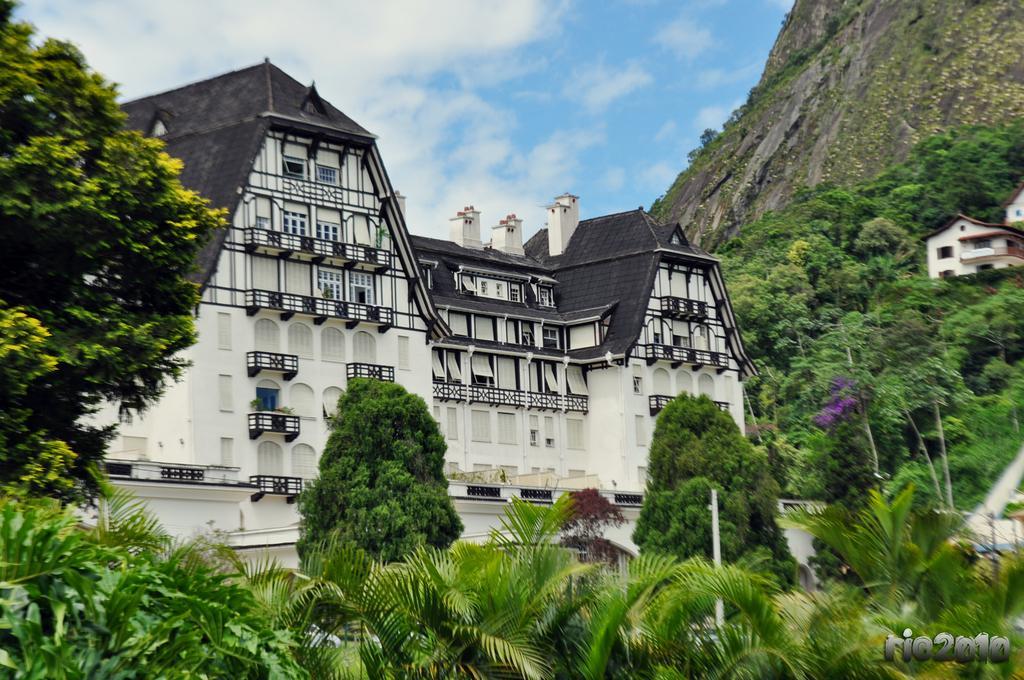Describe this image in one or two sentences. Here we can see trees, buildings and houses. This is pole. Sky is cloudy. 